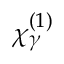<formula> <loc_0><loc_0><loc_500><loc_500>\chi _ { \gamma } ^ { ( 1 ) }</formula> 